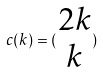<formula> <loc_0><loc_0><loc_500><loc_500>c ( k ) = ( \begin{matrix} 2 k \\ k \end{matrix} )</formula> 